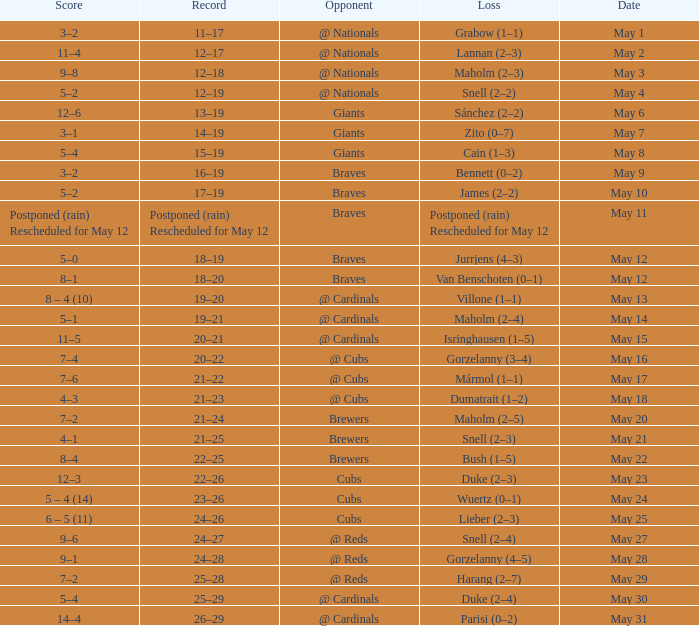What was the date of the game with a loss of Bush (1–5)? May 22. 